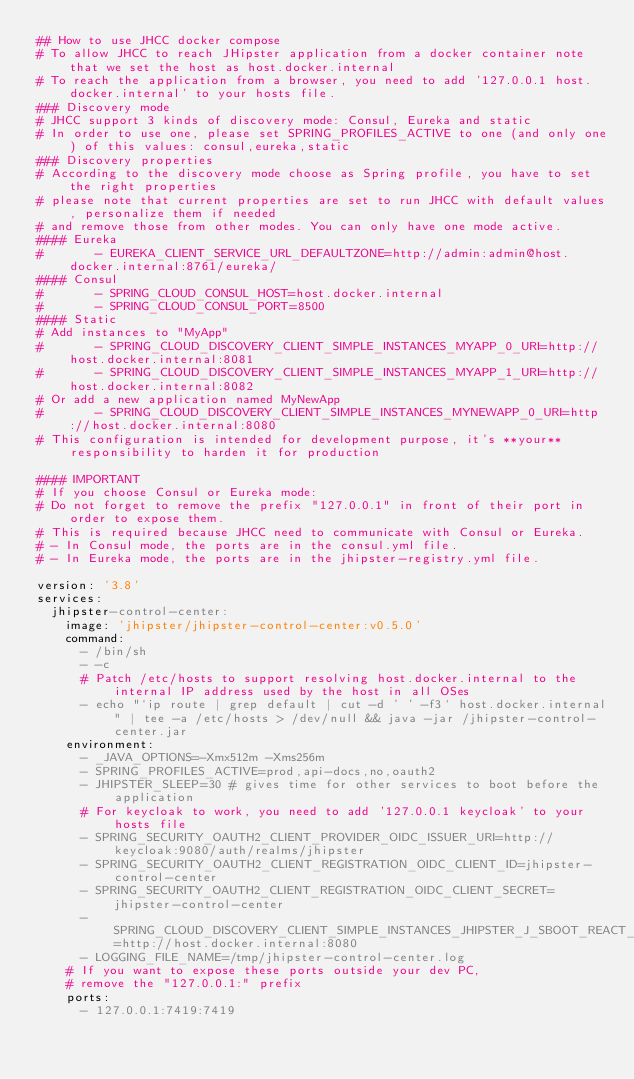<code> <loc_0><loc_0><loc_500><loc_500><_YAML_>## How to use JHCC docker compose
# To allow JHCC to reach JHipster application from a docker container note that we set the host as host.docker.internal
# To reach the application from a browser, you need to add '127.0.0.1 host.docker.internal' to your hosts file.
### Discovery mode
# JHCC support 3 kinds of discovery mode: Consul, Eureka and static
# In order to use one, please set SPRING_PROFILES_ACTIVE to one (and only one) of this values: consul,eureka,static
### Discovery properties
# According to the discovery mode choose as Spring profile, you have to set the right properties
# please note that current properties are set to run JHCC with default values, personalize them if needed
# and remove those from other modes. You can only have one mode active.
#### Eureka
#       - EUREKA_CLIENT_SERVICE_URL_DEFAULTZONE=http://admin:admin@host.docker.internal:8761/eureka/
#### Consul
#       - SPRING_CLOUD_CONSUL_HOST=host.docker.internal
#       - SPRING_CLOUD_CONSUL_PORT=8500
#### Static
# Add instances to "MyApp"
#       - SPRING_CLOUD_DISCOVERY_CLIENT_SIMPLE_INSTANCES_MYAPP_0_URI=http://host.docker.internal:8081
#       - SPRING_CLOUD_DISCOVERY_CLIENT_SIMPLE_INSTANCES_MYAPP_1_URI=http://host.docker.internal:8082
# Or add a new application named MyNewApp
#       - SPRING_CLOUD_DISCOVERY_CLIENT_SIMPLE_INSTANCES_MYNEWAPP_0_URI=http://host.docker.internal:8080
# This configuration is intended for development purpose, it's **your** responsibility to harden it for production

#### IMPORTANT
# If you choose Consul or Eureka mode:
# Do not forget to remove the prefix "127.0.0.1" in front of their port in order to expose them.
# This is required because JHCC need to communicate with Consul or Eureka.
# - In Consul mode, the ports are in the consul.yml file.
# - In Eureka mode, the ports are in the jhipster-registry.yml file.

version: '3.8'
services:
  jhipster-control-center:
    image: 'jhipster/jhipster-control-center:v0.5.0'
    command:
      - /bin/sh
      - -c
      # Patch /etc/hosts to support resolving host.docker.internal to the internal IP address used by the host in all OSes
      - echo "`ip route | grep default | cut -d ' ' -f3` host.docker.internal" | tee -a /etc/hosts > /dev/null && java -jar /jhipster-control-center.jar
    environment:
      - _JAVA_OPTIONS=-Xmx512m -Xms256m
      - SPRING_PROFILES_ACTIVE=prod,api-docs,no,oauth2
      - JHIPSTER_SLEEP=30 # gives time for other services to boot before the application
      # For keycloak to work, you need to add '127.0.0.1 keycloak' to your hosts file
      - SPRING_SECURITY_OAUTH2_CLIENT_PROVIDER_OIDC_ISSUER_URI=http://keycloak:9080/auth/realms/jhipster
      - SPRING_SECURITY_OAUTH2_CLIENT_REGISTRATION_OIDC_CLIENT_ID=jhipster-control-center
      - SPRING_SECURITY_OAUTH2_CLIENT_REGISTRATION_OIDC_CLIENT_SECRET=jhipster-control-center
      - SPRING_CLOUD_DISCOVERY_CLIENT_SIMPLE_INSTANCES_JHIPSTER_J_SBOOT_REACT_0_URI=http://host.docker.internal:8080
      - LOGGING_FILE_NAME=/tmp/jhipster-control-center.log
    # If you want to expose these ports outside your dev PC,
    # remove the "127.0.0.1:" prefix
    ports:
      - 127.0.0.1:7419:7419
</code> 